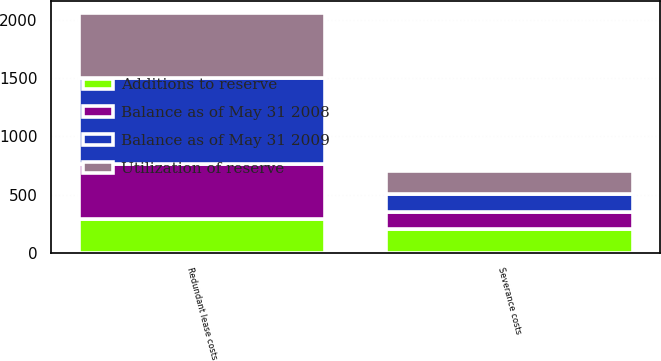<chart> <loc_0><loc_0><loc_500><loc_500><stacked_bar_chart><ecel><fcel>Severance costs<fcel>Redundant lease costs<nl><fcel>Balance as of May 31 2009<fcel>149<fcel>742<nl><fcel>Utilization of reserve<fcel>203<fcel>554<nl><fcel>Additions to reserve<fcel>203<fcel>287<nl><fcel>Balance as of May 31 2008<fcel>149<fcel>475<nl></chart> 